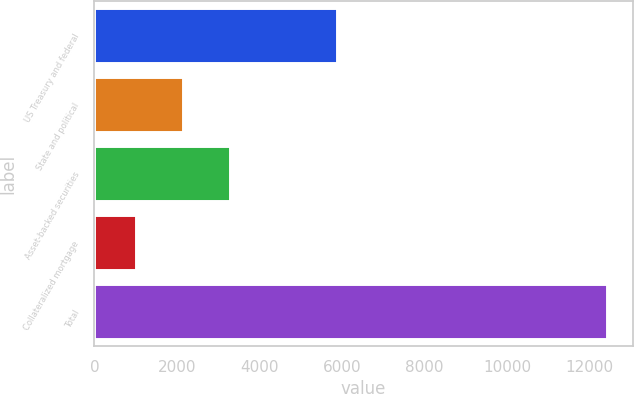Convert chart to OTSL. <chart><loc_0><loc_0><loc_500><loc_500><bar_chart><fcel>US Treasury and federal<fcel>State and political<fcel>Asset-backed securities<fcel>Collateralized mortgage<fcel>Total<nl><fcel>5875<fcel>2150.1<fcel>3291.2<fcel>1009<fcel>12420<nl></chart> 